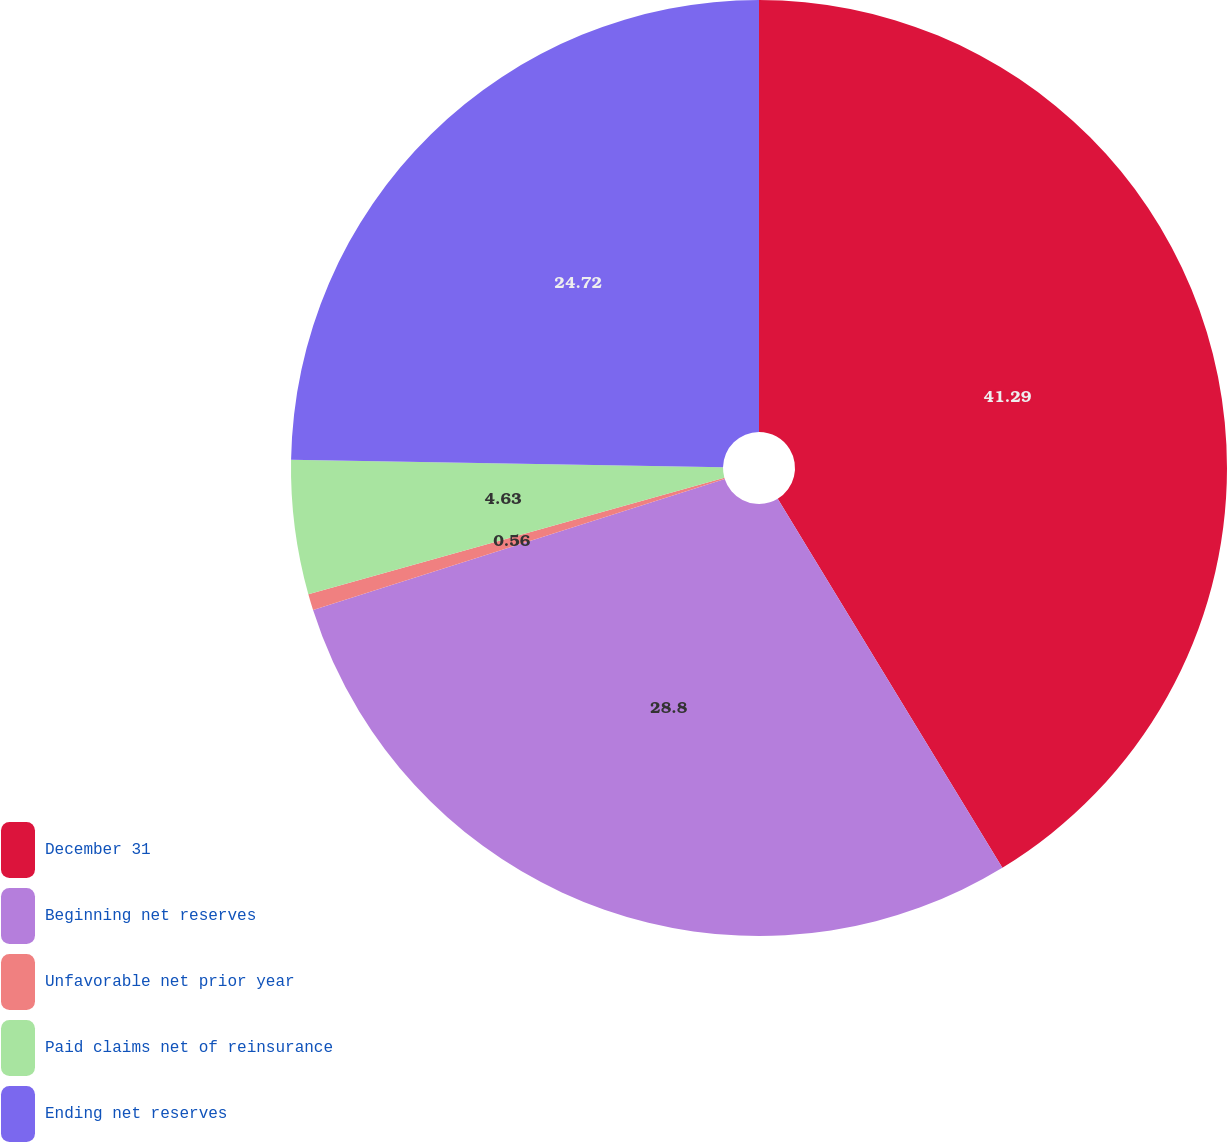Convert chart to OTSL. <chart><loc_0><loc_0><loc_500><loc_500><pie_chart><fcel>December 31<fcel>Beginning net reserves<fcel>Unfavorable net prior year<fcel>Paid claims net of reinsurance<fcel>Ending net reserves<nl><fcel>41.3%<fcel>28.8%<fcel>0.56%<fcel>4.63%<fcel>24.72%<nl></chart> 